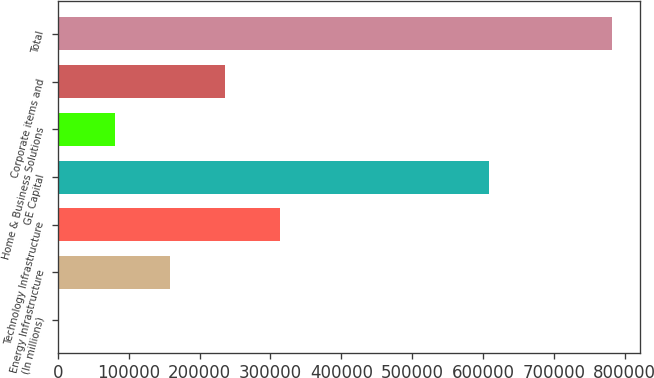Convert chart. <chart><loc_0><loc_0><loc_500><loc_500><bar_chart><fcel>(In millions)<fcel>Energy Infrastructure<fcel>Technology Infrastructure<fcel>GE Capital<fcel>Home & Business Solutions<fcel>Corporate items and<fcel>Total<nl><fcel>2009<fcel>157987<fcel>313966<fcel>607707<fcel>79998.2<fcel>235977<fcel>781901<nl></chart> 